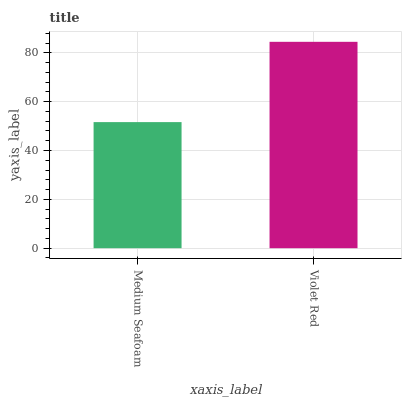Is Medium Seafoam the minimum?
Answer yes or no. Yes. Is Violet Red the maximum?
Answer yes or no. Yes. Is Violet Red the minimum?
Answer yes or no. No. Is Violet Red greater than Medium Seafoam?
Answer yes or no. Yes. Is Medium Seafoam less than Violet Red?
Answer yes or no. Yes. Is Medium Seafoam greater than Violet Red?
Answer yes or no. No. Is Violet Red less than Medium Seafoam?
Answer yes or no. No. Is Violet Red the high median?
Answer yes or no. Yes. Is Medium Seafoam the low median?
Answer yes or no. Yes. Is Medium Seafoam the high median?
Answer yes or no. No. Is Violet Red the low median?
Answer yes or no. No. 